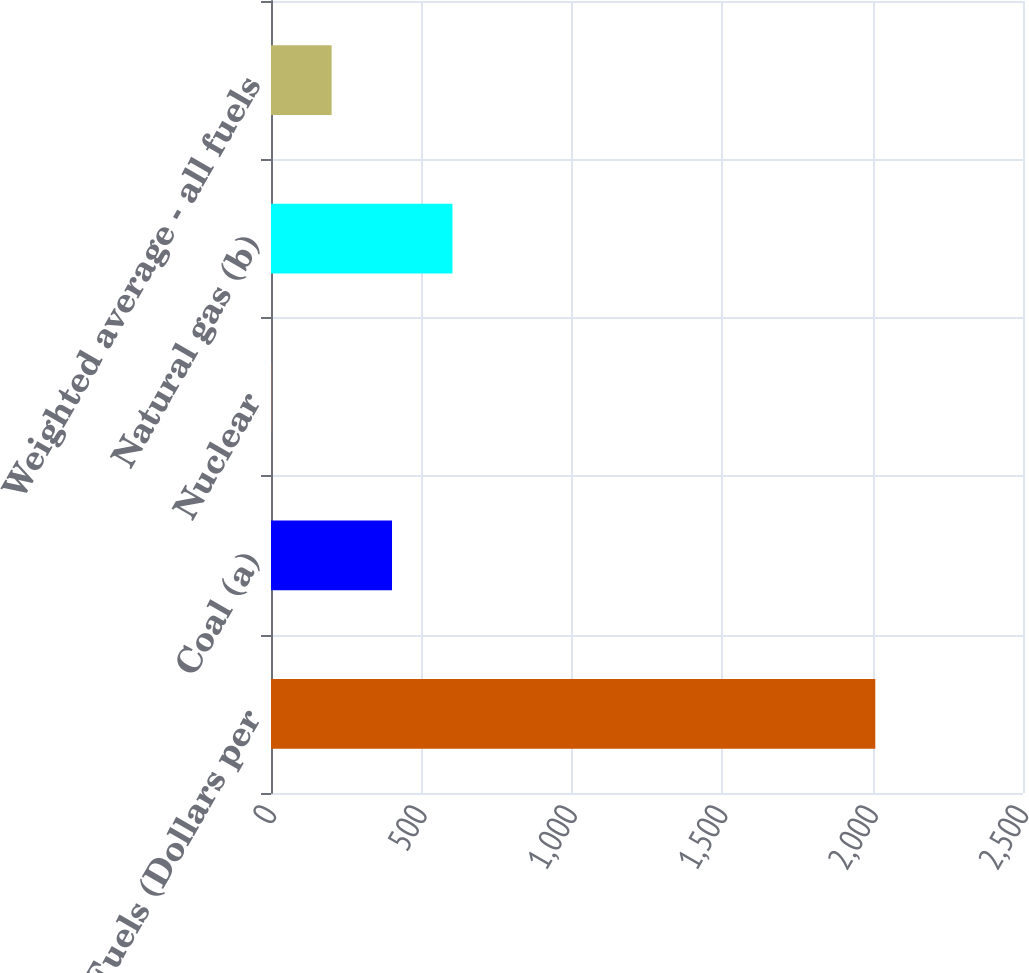<chart> <loc_0><loc_0><loc_500><loc_500><bar_chart><fcel>Cost of Fuels (Dollars per<fcel>Coal (a)<fcel>Nuclear<fcel>Natural gas (b)<fcel>Weighted average - all fuels<nl><fcel>2009<fcel>402.3<fcel>0.62<fcel>603.14<fcel>201.46<nl></chart> 